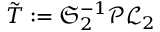<formula> <loc_0><loc_0><loc_500><loc_500>\tilde { T } \colon = \mathfrak { S } _ { 2 } ^ { - 1 } \mathcal { P } \mathcal { L } _ { 2 }</formula> 